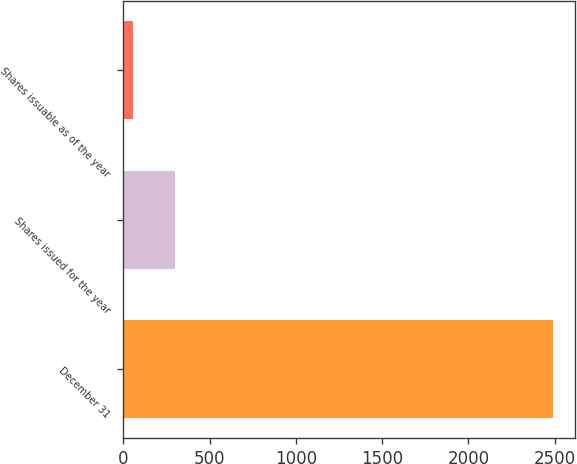Convert chart to OTSL. <chart><loc_0><loc_0><loc_500><loc_500><bar_chart><fcel>December 31<fcel>Shares issued for the year<fcel>Shares issuable as of the year<nl><fcel>2492<fcel>300.5<fcel>57<nl></chart> 